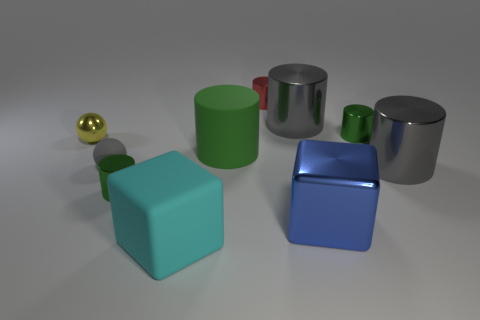Are there any big blue metal things of the same shape as the big cyan rubber thing?
Offer a very short reply. Yes. Is the number of big green matte objects in front of the rubber block the same as the number of tiny green cylinders that are to the right of the tiny yellow object?
Keep it short and to the point. No. There is a small object to the left of the rubber sphere; is it the same shape as the small gray thing?
Offer a very short reply. Yes. Is the tiny yellow metal thing the same shape as the gray rubber thing?
Offer a terse response. Yes. How many rubber objects are big blue blocks or tiny gray balls?
Ensure brevity in your answer.  1. Do the red thing and the gray matte sphere have the same size?
Your response must be concise. Yes. What number of things are rubber things or gray cylinders that are to the right of the large blue thing?
Offer a terse response. 4. What material is the cube that is the same size as the cyan matte thing?
Your response must be concise. Metal. There is a large object that is in front of the large green thing and to the left of the small red object; what material is it made of?
Make the answer very short. Rubber. Are there any green metallic objects that are on the right side of the small green shiny thing in front of the small metal sphere?
Offer a terse response. Yes. 